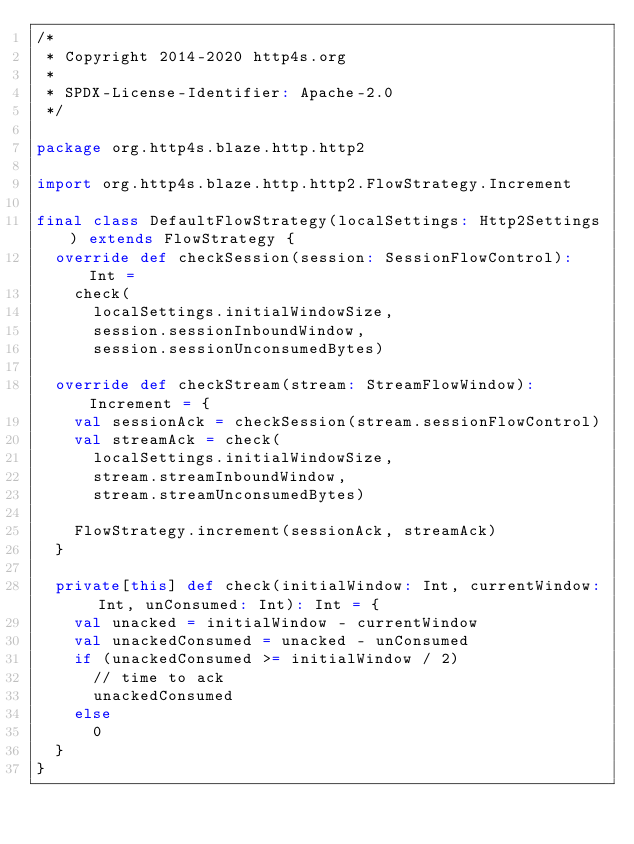Convert code to text. <code><loc_0><loc_0><loc_500><loc_500><_Scala_>/*
 * Copyright 2014-2020 http4s.org
 *
 * SPDX-License-Identifier: Apache-2.0
 */

package org.http4s.blaze.http.http2

import org.http4s.blaze.http.http2.FlowStrategy.Increment

final class DefaultFlowStrategy(localSettings: Http2Settings) extends FlowStrategy {
  override def checkSession(session: SessionFlowControl): Int =
    check(
      localSettings.initialWindowSize,
      session.sessionInboundWindow,
      session.sessionUnconsumedBytes)

  override def checkStream(stream: StreamFlowWindow): Increment = {
    val sessionAck = checkSession(stream.sessionFlowControl)
    val streamAck = check(
      localSettings.initialWindowSize,
      stream.streamInboundWindow,
      stream.streamUnconsumedBytes)

    FlowStrategy.increment(sessionAck, streamAck)
  }

  private[this] def check(initialWindow: Int, currentWindow: Int, unConsumed: Int): Int = {
    val unacked = initialWindow - currentWindow
    val unackedConsumed = unacked - unConsumed
    if (unackedConsumed >= initialWindow / 2)
      // time to ack
      unackedConsumed
    else
      0
  }
}
</code> 